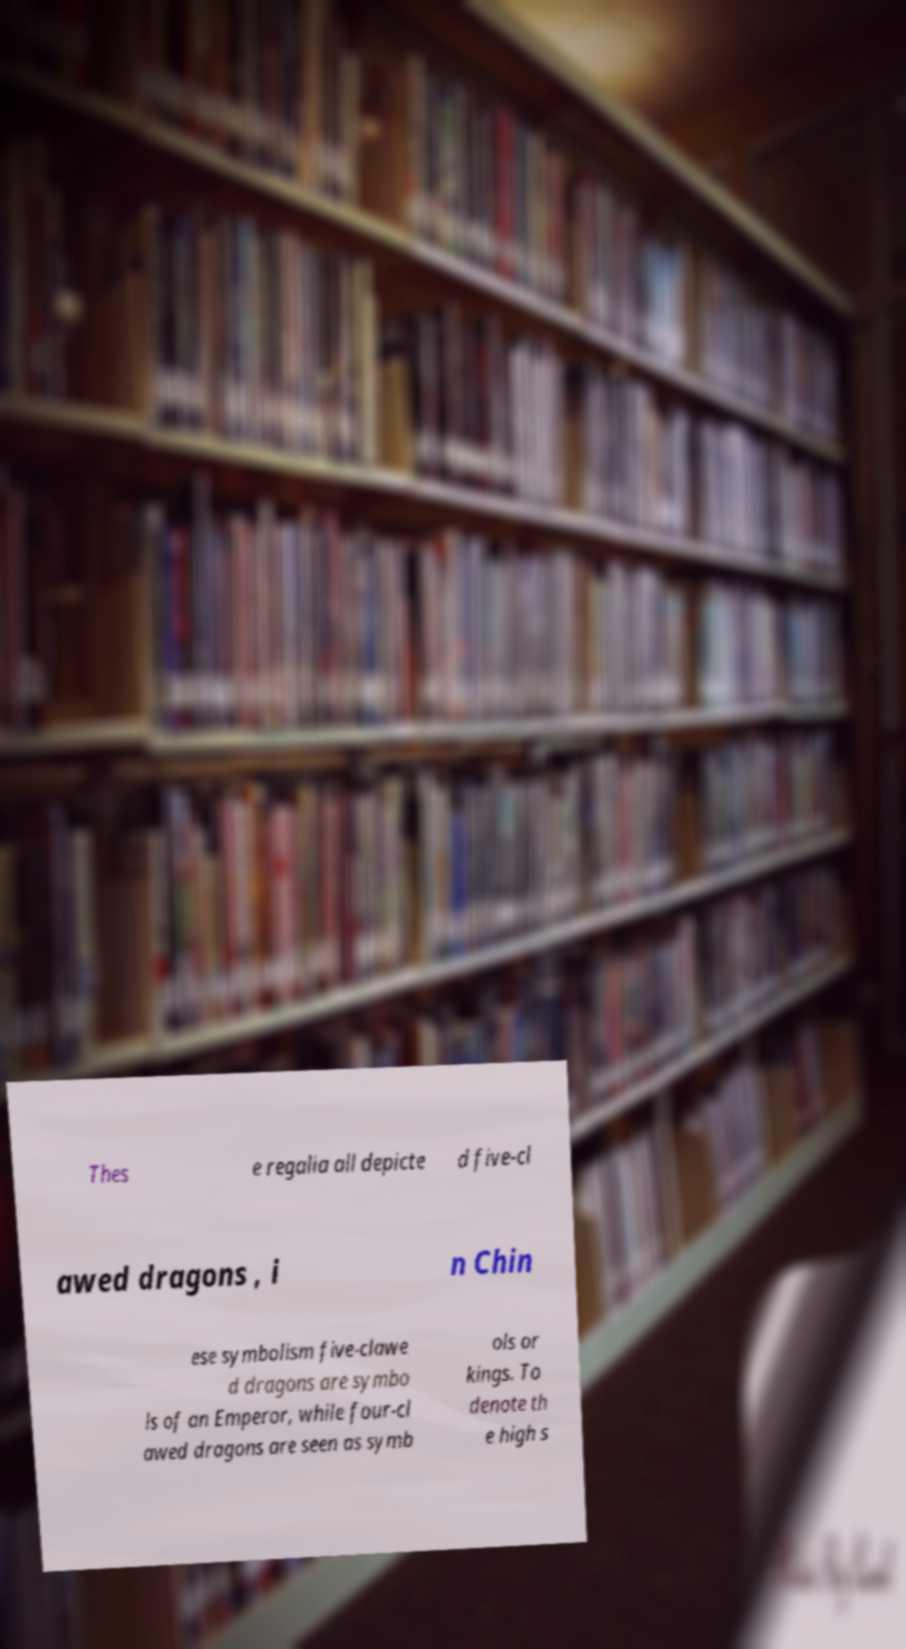Please read and relay the text visible in this image. What does it say? Thes e regalia all depicte d five-cl awed dragons , i n Chin ese symbolism five-clawe d dragons are symbo ls of an Emperor, while four-cl awed dragons are seen as symb ols or kings. To denote th e high s 